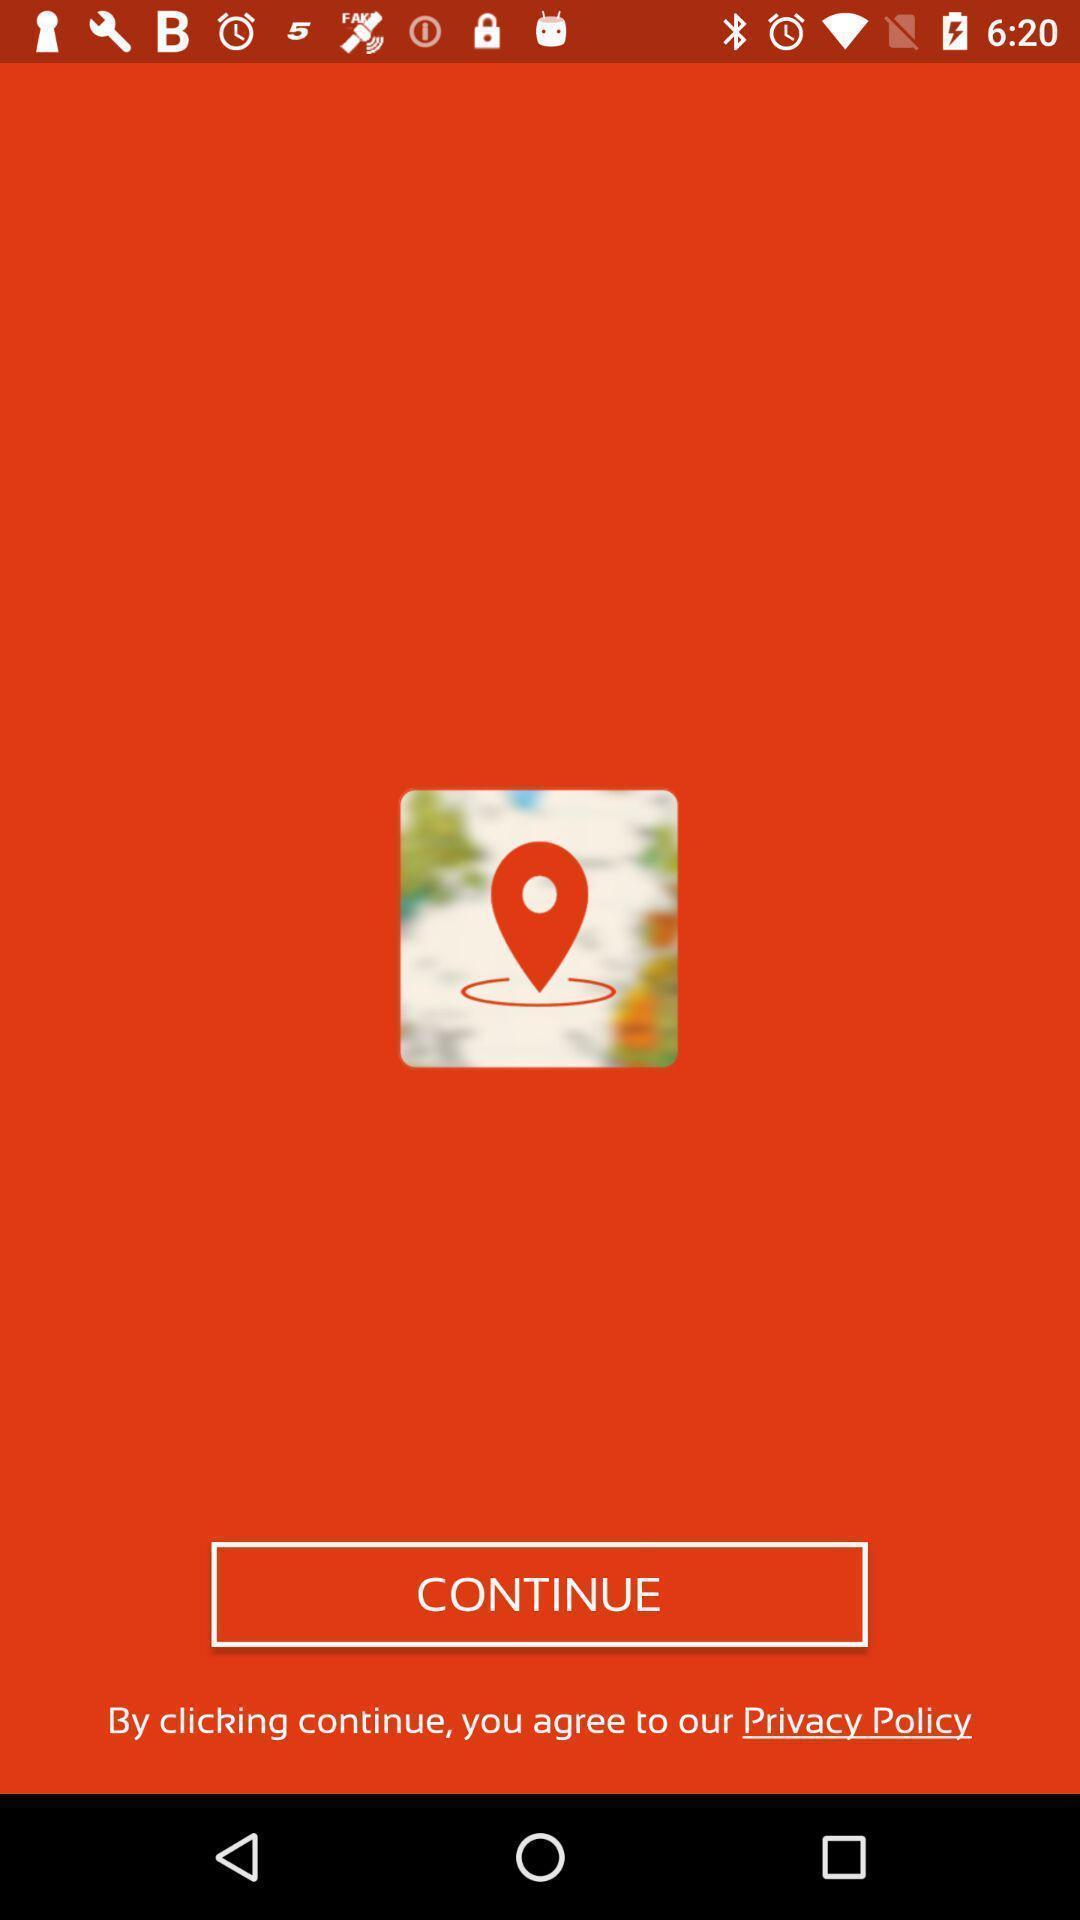Describe the content in this image. Page displaying to continue for an app. 